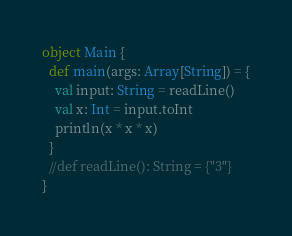Convert code to text. <code><loc_0><loc_0><loc_500><loc_500><_Scala_>object Main {
  def main(args: Array[String]) = {
    val input: String = readLine()
    val x: Int = input.toInt
    println(x * x * x)
  }  
  //def readLine(): String = {"3"}
}
</code> 